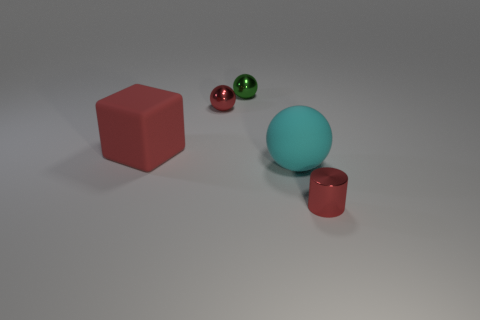Subtract all large matte balls. How many balls are left? 2 Add 3 tiny cylinders. How many objects exist? 8 Subtract all purple balls. Subtract all red blocks. How many balls are left? 3 Subtract all spheres. How many objects are left? 2 Subtract all purple shiny balls. Subtract all large cyan objects. How many objects are left? 4 Add 5 cyan balls. How many cyan balls are left? 6 Add 1 small green shiny balls. How many small green shiny balls exist? 2 Subtract 0 gray cylinders. How many objects are left? 5 